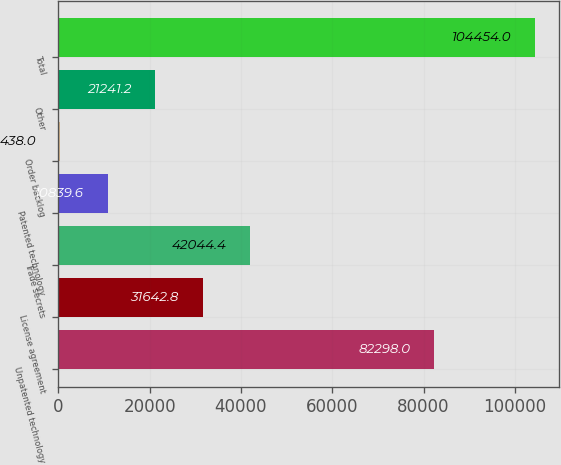Convert chart to OTSL. <chart><loc_0><loc_0><loc_500><loc_500><bar_chart><fcel>Unpatented technology<fcel>License agreement<fcel>Trade secrets<fcel>Patented technology<fcel>Order backlog<fcel>Other<fcel>Total<nl><fcel>82298<fcel>31642.8<fcel>42044.4<fcel>10839.6<fcel>438<fcel>21241.2<fcel>104454<nl></chart> 